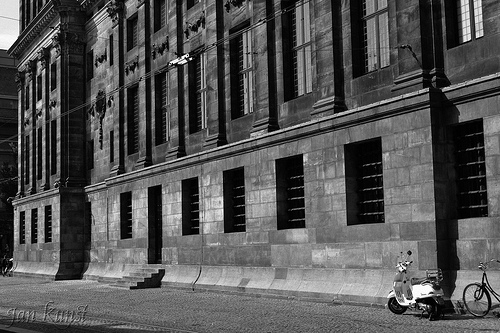Can you provide a short story involving the scooter in the image? The scooter in the image belongs to a young artist named Leo, who visits this spot every morning. Leo parks his scooter here and sets up his easel to capture the building’s intricate details. He loves the play of light and shadows on the stone walls. This building has become his muse, and he dreams of one day holding an exhibition featuring paintings of this historic site. 